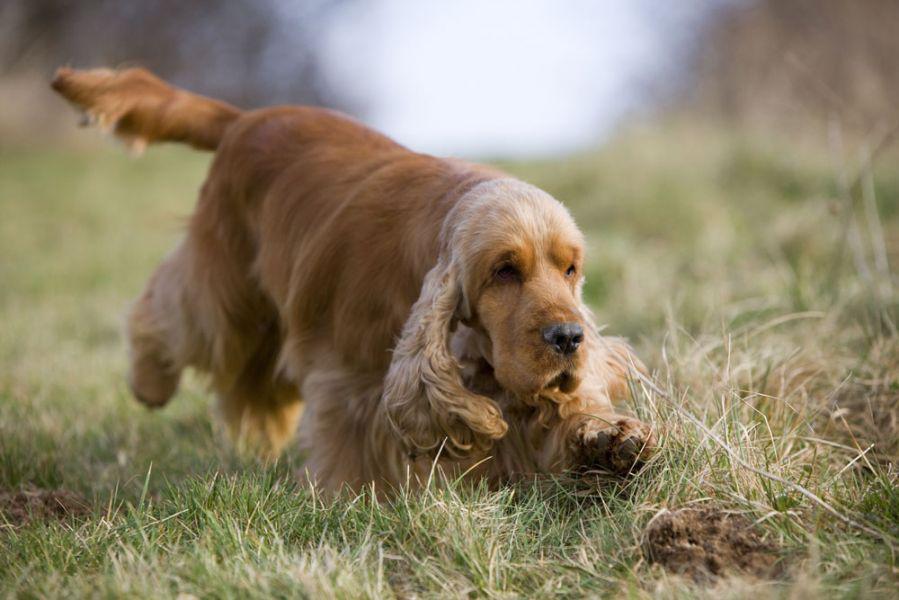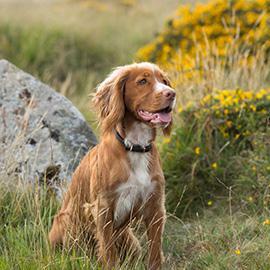The first image is the image on the left, the second image is the image on the right. Given the left and right images, does the statement "One image shows a mostly gold dog sitting upright, and the other shows a dog moving forward over the grass." hold true? Answer yes or no. Yes. The first image is the image on the left, the second image is the image on the right. For the images displayed, is the sentence "The dog in the image on the left is sitting on the grass." factually correct? Answer yes or no. No. 